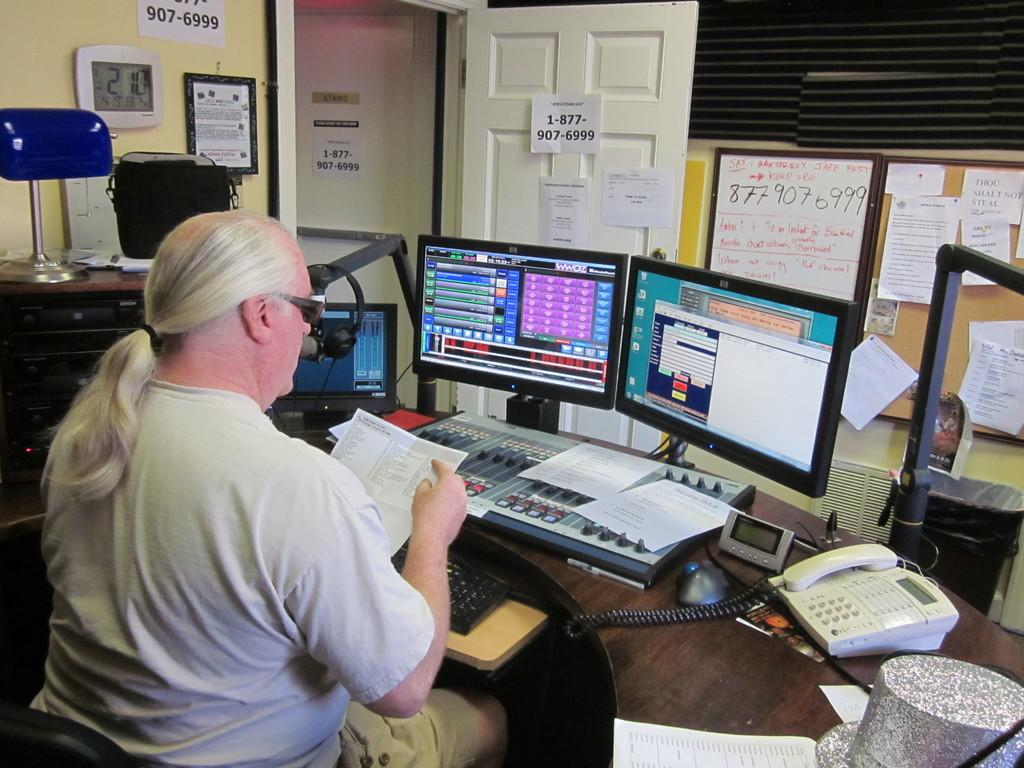Provide a one-sentence caption for the provided image. A man works in a studio, with the phone number 1-877-907-6999 posted on the door in front of him. 